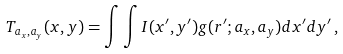<formula> <loc_0><loc_0><loc_500><loc_500>T _ { a _ { x } , a _ { y } } ( x , y ) = \int \int I ( x ^ { \prime } , y ^ { \prime } ) g ( r ^ { \prime } ; a _ { x } , a _ { y } ) d x ^ { \prime } d y ^ { \prime } \, ,</formula> 